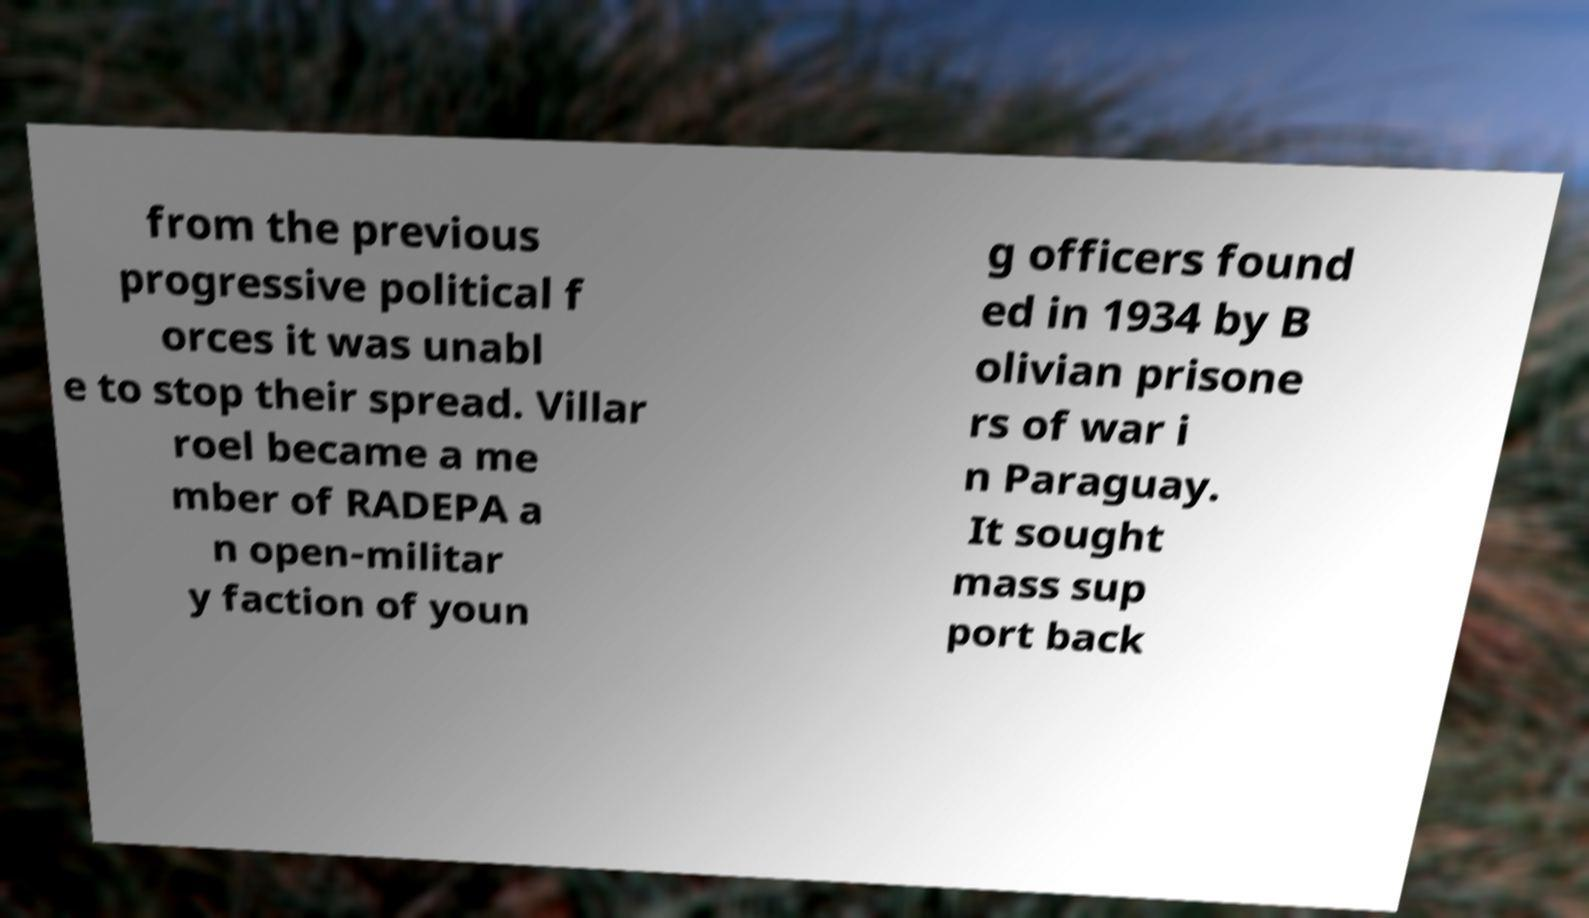Can you accurately transcribe the text from the provided image for me? from the previous progressive political f orces it was unabl e to stop their spread. Villar roel became a me mber of RADEPA a n open-militar y faction of youn g officers found ed in 1934 by B olivian prisone rs of war i n Paraguay. It sought mass sup port back 